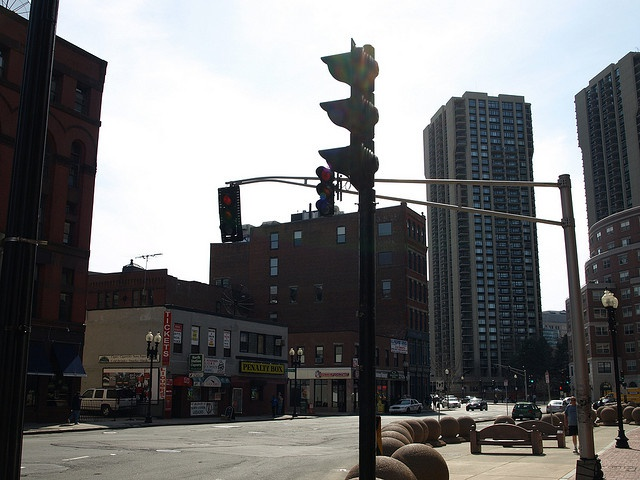Describe the objects in this image and their specific colors. I can see traffic light in darkgray, black, gray, and teal tones, bench in darkgray, black, gray, and ivory tones, car in darkgray, black, and gray tones, traffic light in darkgray, black, gray, maroon, and lightgray tones, and bench in darkgray, black, and gray tones in this image. 